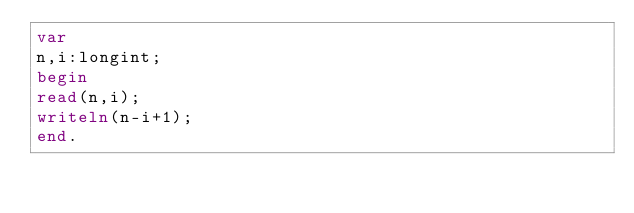Convert code to text. <code><loc_0><loc_0><loc_500><loc_500><_Pascal_>var
n,i:longint;
begin
read(n,i);
writeln(n-i+1);
end.</code> 